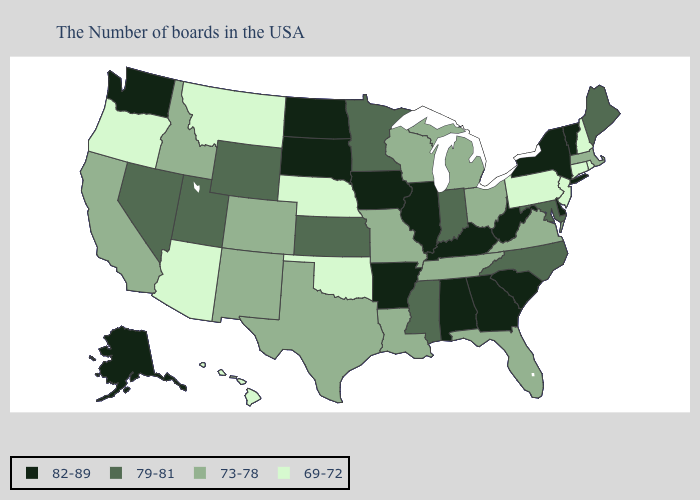What is the value of Minnesota?
Keep it brief. 79-81. What is the value of Texas?
Quick response, please. 73-78. Name the states that have a value in the range 73-78?
Be succinct. Massachusetts, Virginia, Ohio, Florida, Michigan, Tennessee, Wisconsin, Louisiana, Missouri, Texas, Colorado, New Mexico, Idaho, California. Does Michigan have a lower value than Utah?
Answer briefly. Yes. What is the value of Hawaii?
Answer briefly. 69-72. What is the value of Arkansas?
Concise answer only. 82-89. Name the states that have a value in the range 79-81?
Keep it brief. Maine, Maryland, North Carolina, Indiana, Mississippi, Minnesota, Kansas, Wyoming, Utah, Nevada. Does the first symbol in the legend represent the smallest category?
Give a very brief answer. No. Name the states that have a value in the range 79-81?
Be succinct. Maine, Maryland, North Carolina, Indiana, Mississippi, Minnesota, Kansas, Wyoming, Utah, Nevada. How many symbols are there in the legend?
Give a very brief answer. 4. Does the first symbol in the legend represent the smallest category?
Be succinct. No. What is the value of Tennessee?
Give a very brief answer. 73-78. Name the states that have a value in the range 82-89?
Short answer required. Vermont, New York, Delaware, South Carolina, West Virginia, Georgia, Kentucky, Alabama, Illinois, Arkansas, Iowa, South Dakota, North Dakota, Washington, Alaska. Does the map have missing data?
Write a very short answer. No. Among the states that border Louisiana , does Mississippi have the highest value?
Keep it brief. No. 